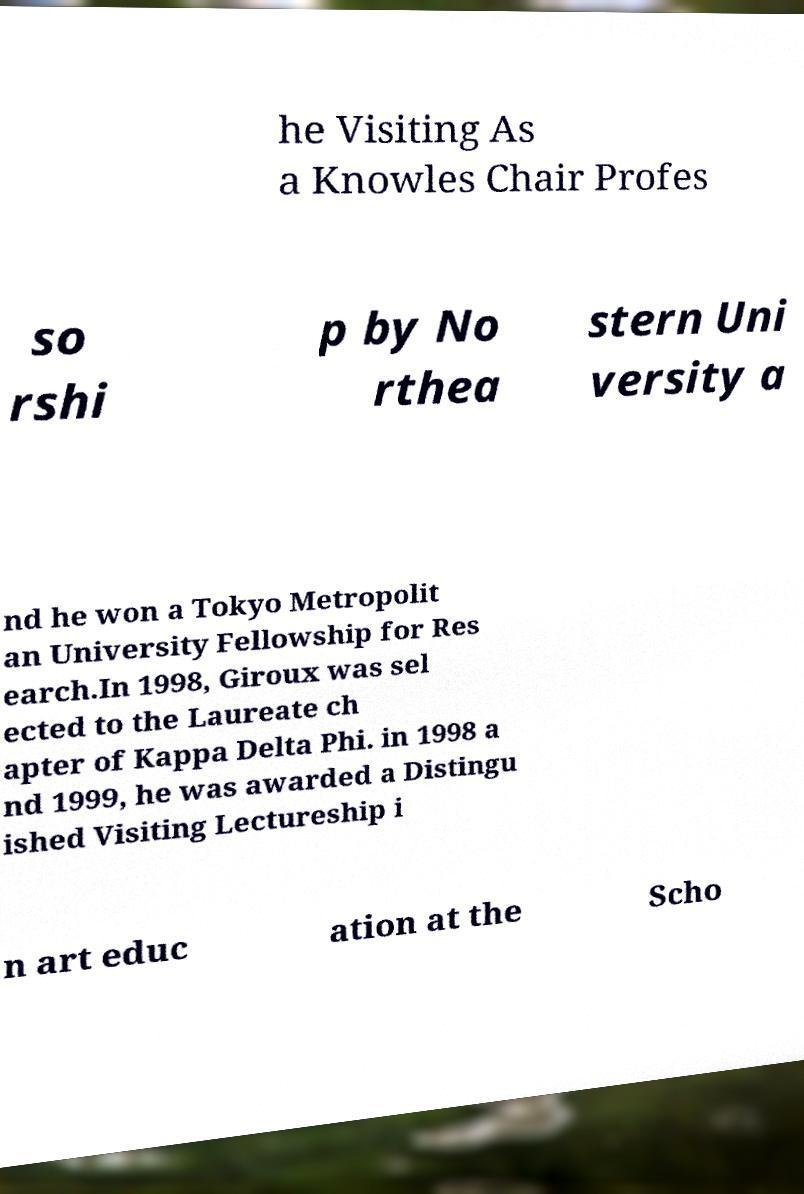I need the written content from this picture converted into text. Can you do that? he Visiting As a Knowles Chair Profes so rshi p by No rthea stern Uni versity a nd he won a Tokyo Metropolit an University Fellowship for Res earch.In 1998, Giroux was sel ected to the Laureate ch apter of Kappa Delta Phi. in 1998 a nd 1999, he was awarded a Distingu ished Visiting Lectureship i n art educ ation at the Scho 